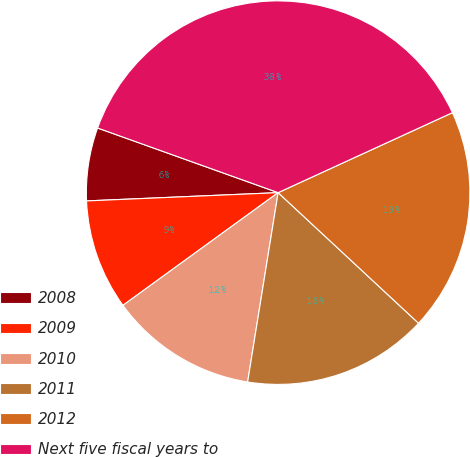Convert chart to OTSL. <chart><loc_0><loc_0><loc_500><loc_500><pie_chart><fcel>2008<fcel>2009<fcel>2010<fcel>2011<fcel>2012<fcel>Next five fiscal years to<nl><fcel>6.16%<fcel>9.31%<fcel>12.46%<fcel>15.62%<fcel>18.77%<fcel>37.68%<nl></chart> 